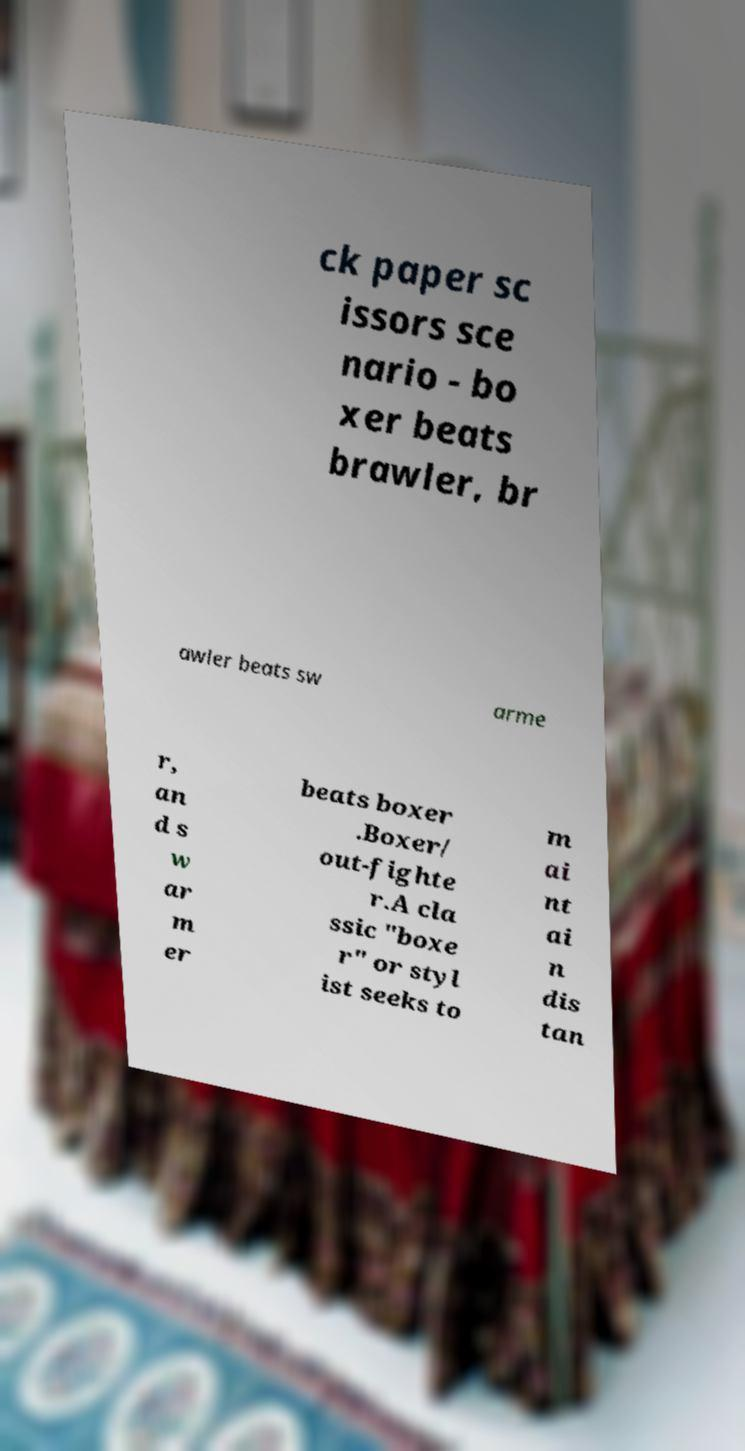There's text embedded in this image that I need extracted. Can you transcribe it verbatim? ck paper sc issors sce nario - bo xer beats brawler, br awler beats sw arme r, an d s w ar m er beats boxer .Boxer/ out-fighte r.A cla ssic "boxe r" or styl ist seeks to m ai nt ai n dis tan 